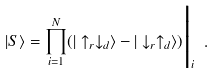Convert formula to latex. <formula><loc_0><loc_0><loc_500><loc_500>| S \rangle = \prod _ { i = 1 } ^ { N } ( | \uparrow _ { r } \downarrow _ { d } \rangle - | \downarrow _ { r } \uparrow _ { d } \rangle ) \Big | _ { i } \ .</formula> 